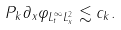<formula> <loc_0><loc_0><loc_500><loc_500>\| P _ { k } \partial _ { x } \varphi \| _ { L _ { t } ^ { \infty } L _ { x } ^ { 2 } } \lesssim c _ { k } .</formula> 